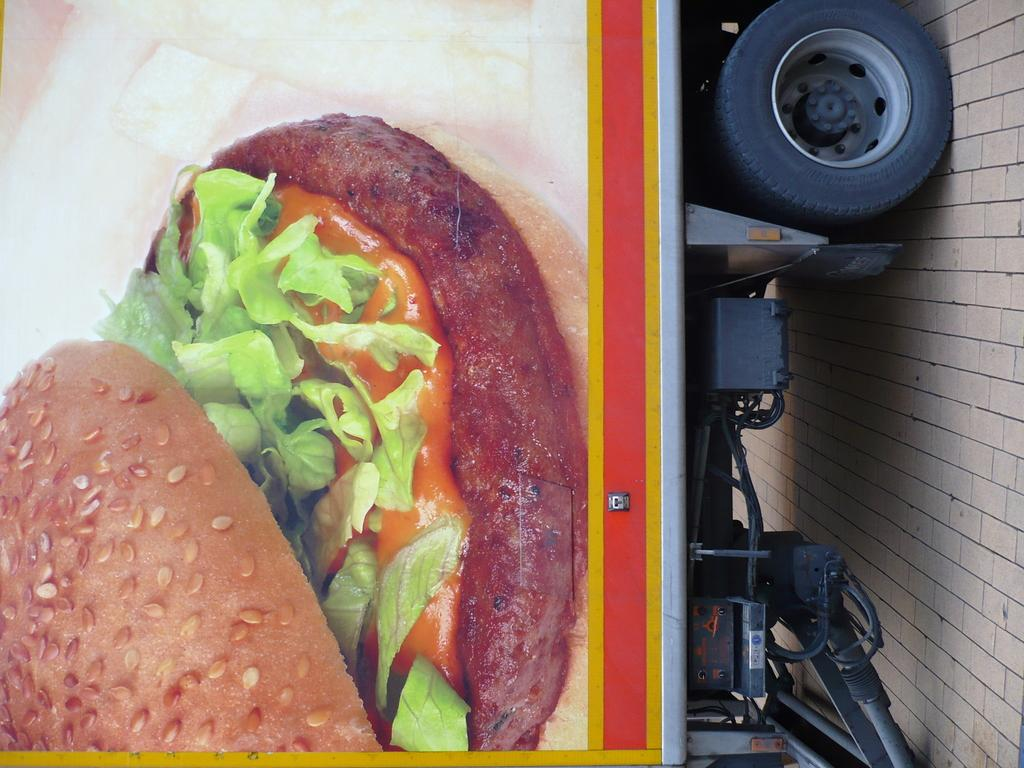What is the main subject of the image? There is a vehicle in the image. What is on the vehicle? There is food on the vehicle. What can be seen on the right side of the image? The ground is visible towards the right of the image. How many girls are standing on the dock in the image? There is no dock or girls present in the image. 